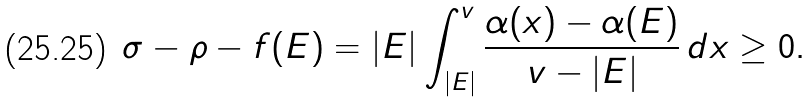<formula> <loc_0><loc_0><loc_500><loc_500>\sigma - \rho - f ( E ) = | E | \int _ { | E | } ^ { v } \frac { \alpha ( x ) - \alpha ( E ) } { v - | E | } \, d x \geq 0 .</formula> 